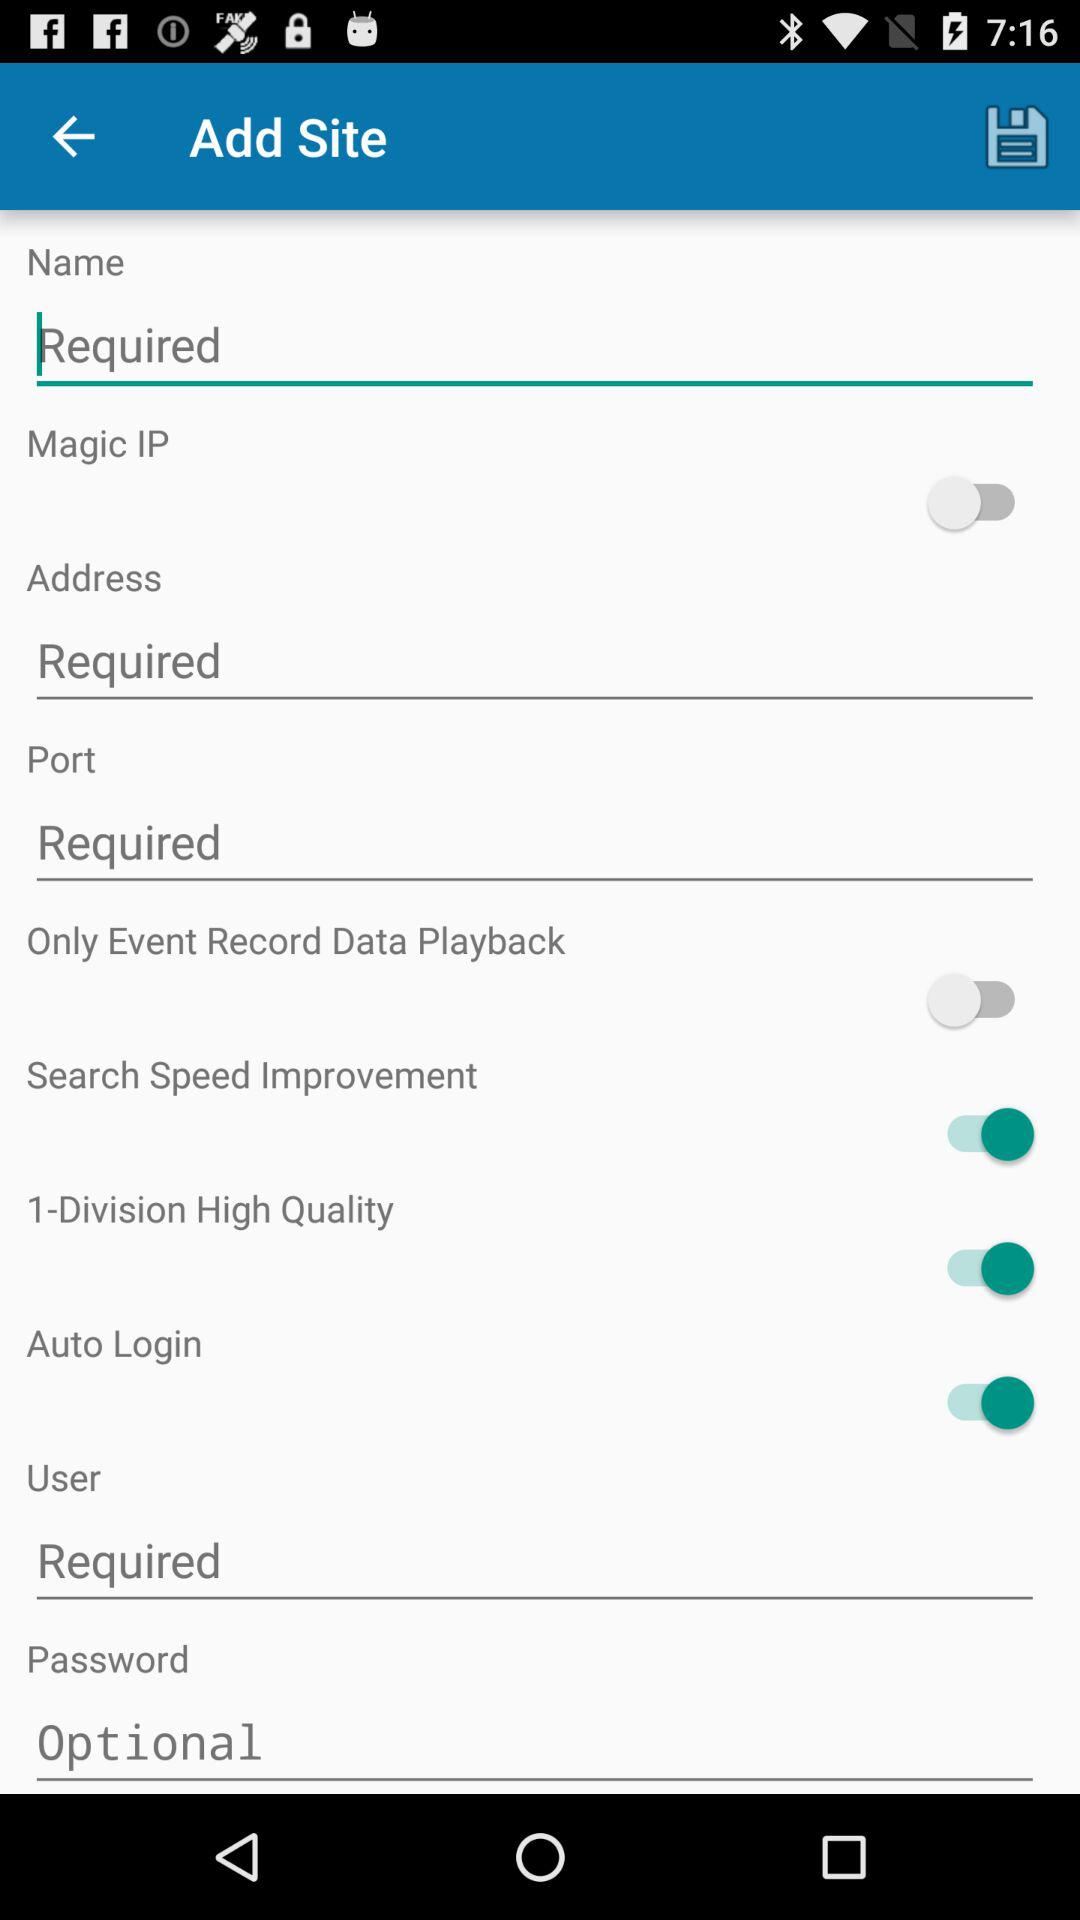What options have been disabled? The disabled options are "Magic IP" and "Only Event Record Data Playback". 